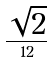Convert formula to latex. <formula><loc_0><loc_0><loc_500><loc_500>\frac { \sqrt { 2 } } { 1 2 }</formula> 